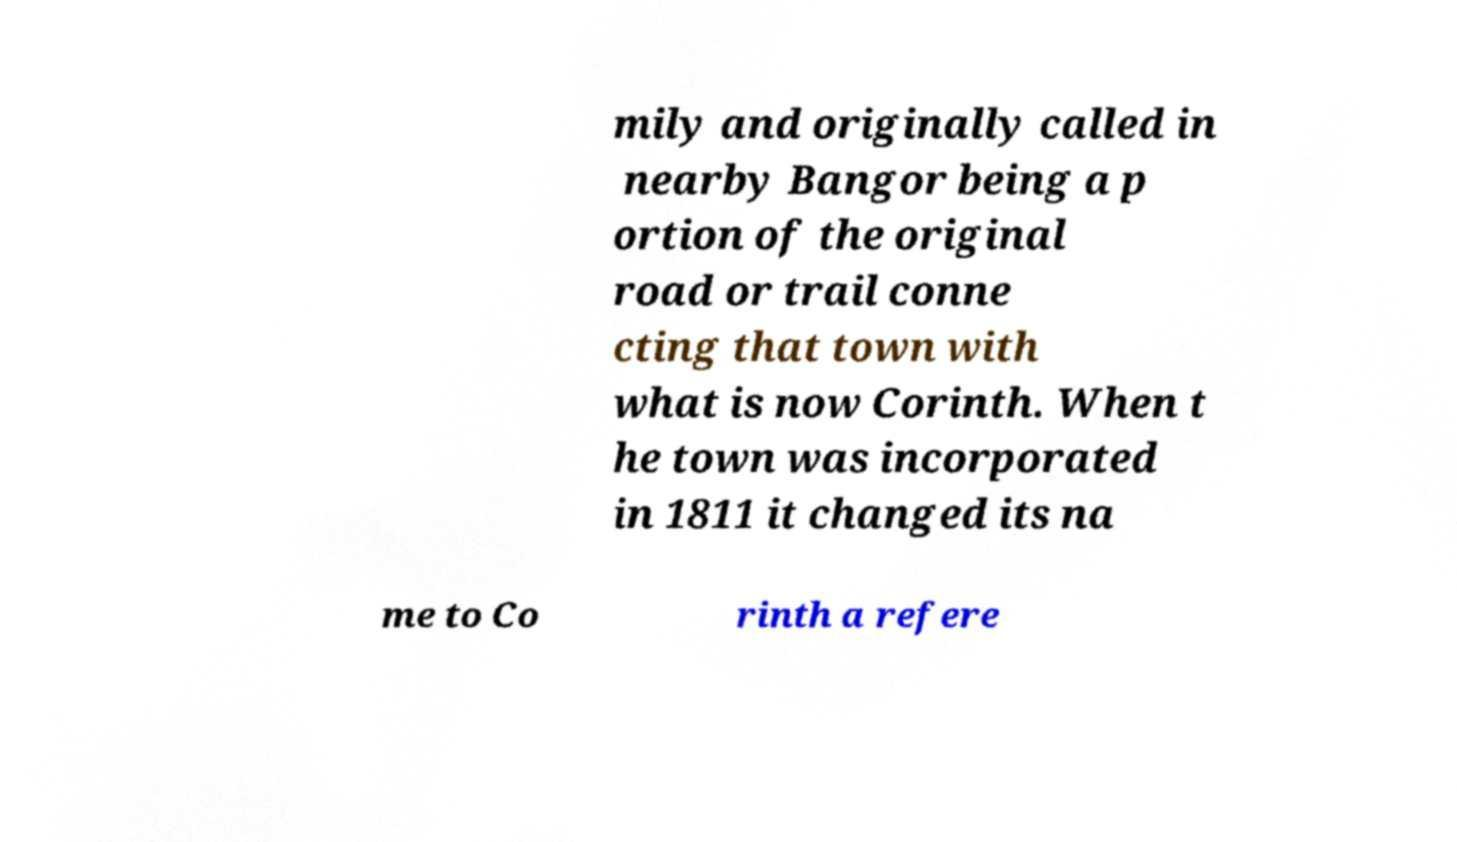Can you accurately transcribe the text from the provided image for me? mily and originally called in nearby Bangor being a p ortion of the original road or trail conne cting that town with what is now Corinth. When t he town was incorporated in 1811 it changed its na me to Co rinth a refere 